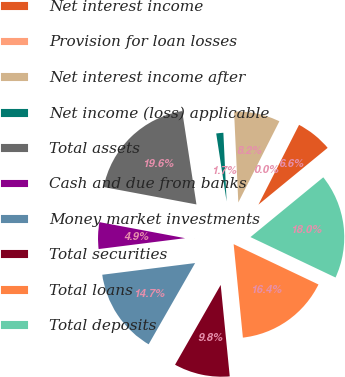Convert chart. <chart><loc_0><loc_0><loc_500><loc_500><pie_chart><fcel>Net interest income<fcel>Provision for loan losses<fcel>Net interest income after<fcel>Net income (loss) applicable<fcel>Total assets<fcel>Cash and due from banks<fcel>Money market investments<fcel>Total securities<fcel>Total loans<fcel>Total deposits<nl><fcel>6.57%<fcel>0.04%<fcel>8.2%<fcel>1.67%<fcel>19.64%<fcel>4.94%<fcel>14.74%<fcel>9.84%<fcel>16.37%<fcel>18.0%<nl></chart> 